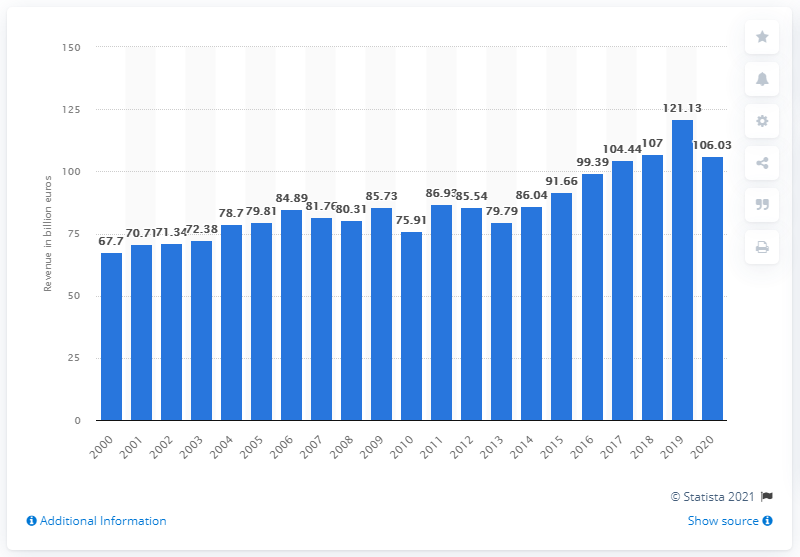Specify some key components in this picture. In 2020, the revenue of the new car market in Germany was 106.03 million. 